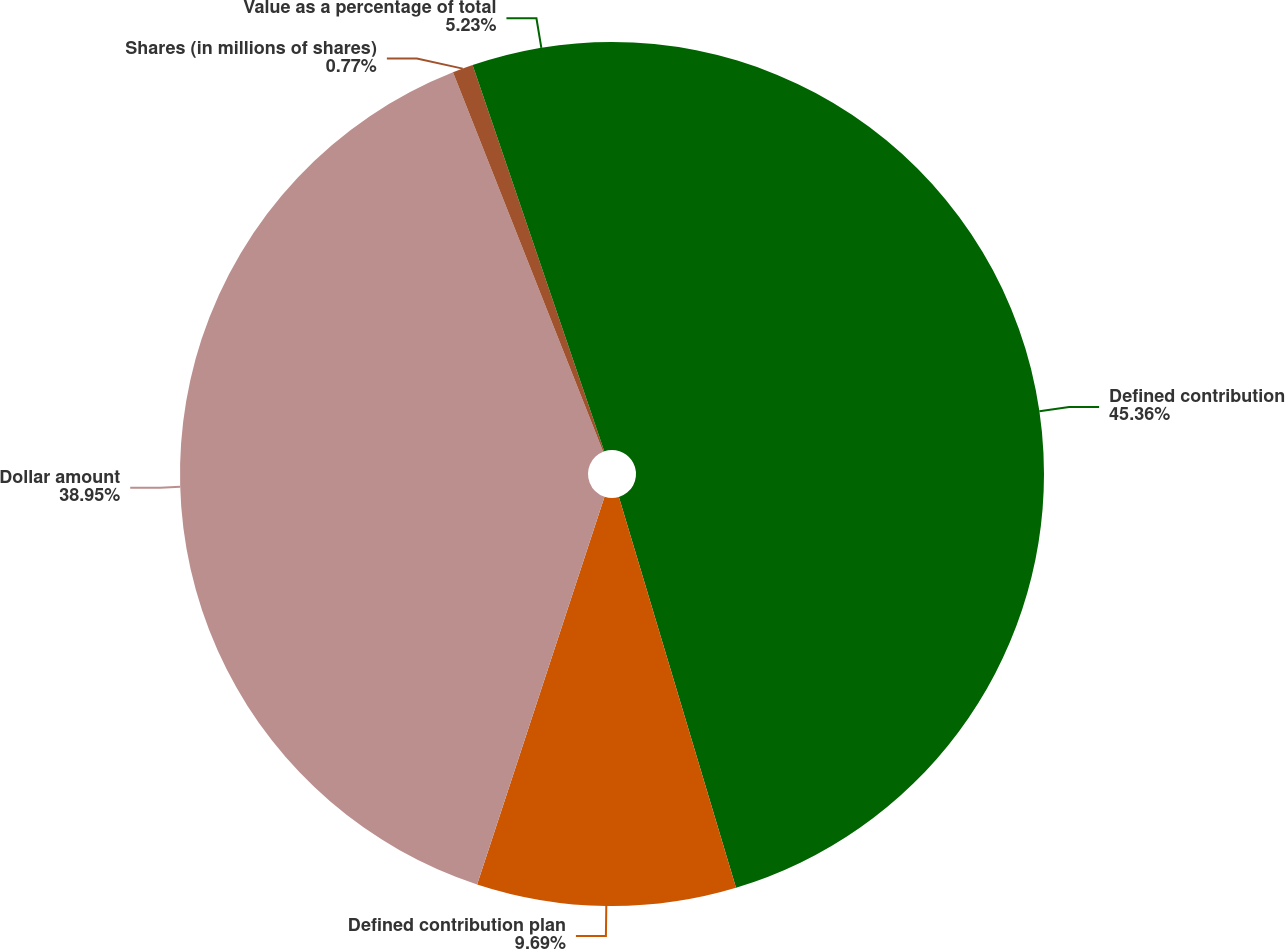<chart> <loc_0><loc_0><loc_500><loc_500><pie_chart><fcel>Defined contribution<fcel>Defined contribution plan<fcel>Dollar amount<fcel>Shares (in millions of shares)<fcel>Value as a percentage of total<nl><fcel>45.37%<fcel>9.69%<fcel>38.95%<fcel>0.77%<fcel>5.23%<nl></chart> 